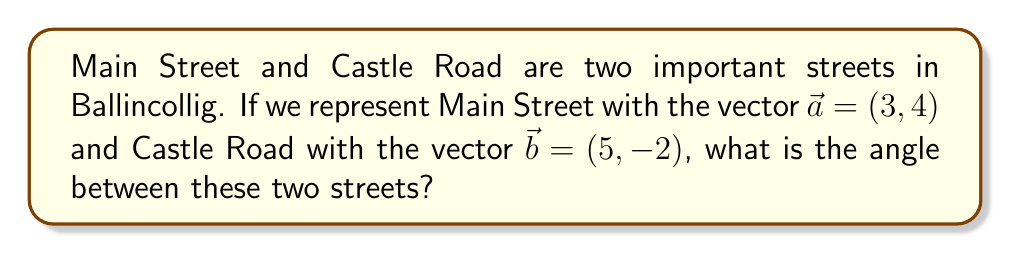Solve this math problem. To find the angle between two vectors, we can use the dot product formula:

$$\cos \theta = \frac{\vec{a} \cdot \vec{b}}{|\vec{a}||\vec{b}|}$$

Where $\theta$ is the angle between the vectors, $\vec{a} \cdot \vec{b}$ is the dot product of the vectors, and $|\vec{a}|$ and $|\vec{b}|$ are the magnitudes of the vectors.

Step 1: Calculate the dot product $\vec{a} \cdot \vec{b}$
$$\vec{a} \cdot \vec{b} = (3)(5) + (4)(-2) = 15 - 8 = 7$$

Step 2: Calculate the magnitudes of the vectors
$$|\vec{a}| = \sqrt{3^2 + 4^2} = \sqrt{9 + 16} = \sqrt{25} = 5$$
$$|\vec{b}| = \sqrt{5^2 + (-2)^2} = \sqrt{25 + 4} = \sqrt{29}$$

Step 3: Substitute into the formula
$$\cos \theta = \frac{7}{5\sqrt{29}}$$

Step 4: Take the inverse cosine (arccos) of both sides
$$\theta = \arccos\left(\frac{7}{5\sqrt{29}}\right)$$

Step 5: Calculate the result (rounded to two decimal places)
$$\theta \approx 1.20 \text{ radians}$$

Convert to degrees:
$$\theta \approx 1.20 \times \frac{180}{\pi} \approx 68.75°$$

[asy]
import geometry;

pair a = (3,4);
pair b = (5,-2);
pair O = (0,0);

draw(O--a,Arrow);
draw(O--b,Arrow);

label("Main Street $\vec{a}$", a, NE);
label("Castle Road $\vec{b}$", b, SE);

draw(arc(O,1,0,degrees(atan2(a.y,a.x))),blue);
label("$\theta$", (0.7,0.3), blue);
[/asy]
Answer: The angle between Main Street and Castle Road in Ballincollig is approximately 68.75°. 